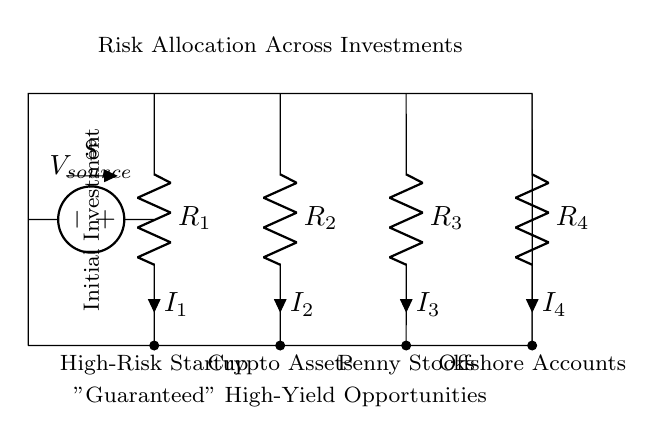What is the source voltage in this circuit? The source voltage is indicated as \$V_{source}\$, which represents the initial investment amount that would be allocated across the different investments.
Answer: V source Which investment has the highest risk? The investment labeled as "High-Risk Startup" corresponds to resistor R1, which indicates it has a higher risk compared to the others.
Answer: High-Risk Startup What is the total current flowing through the circuit? The total current is the summation of currents through all the resistors (I1, I2, I3, I4) in the parallel circuit, but is not depicted in the circuit diagram. Typically, this would be equal to the source current, denoted by the sum of the individual currents.
Answer: Not specified Which component corresponds to the least risky investment? The investment labeled "Offshore Accounts" corresponds to resistor R4, which suggests it is the least risky compared to others in this circuit.
Answer: Offshore Accounts How many investment opportunities are shown in the circuit? The circuit diagram includes four investment opportunities: High-Risk Startup, Crypto Assets, Penny Stocks, and Offshore Accounts.
Answer: Four If all resistors have equal resistance, how is the current distributed? In a current divider circuit where all resistors have equal resistance, the total current would be divided equally among all resistors, meaning each resistor would carry one-fourth of the total current. This highlights the principle of current division in parallel resistors.
Answer: Equal distribution 